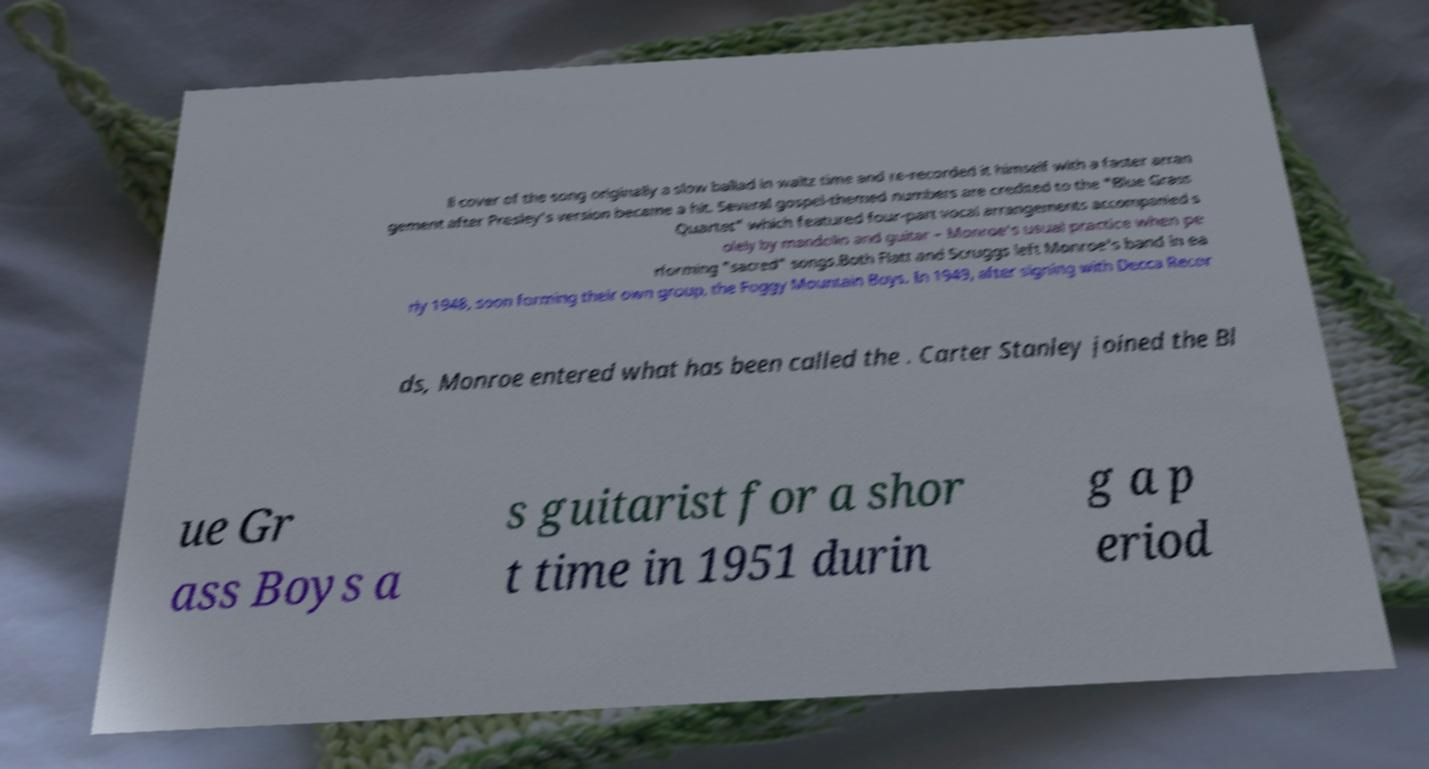Could you extract and type out the text from this image? ll cover of the song originally a slow ballad in waltz time and re-recorded it himself with a faster arran gement after Presley's version became a hit. Several gospel-themed numbers are credited to the "Blue Grass Quartet" which featured four-part vocal arrangements accompanied s olely by mandolin and guitar – Monroe's usual practice when pe rforming "sacred" songs.Both Flatt and Scruggs left Monroe's band in ea rly 1948, soon forming their own group, the Foggy Mountain Boys. In 1949, after signing with Decca Recor ds, Monroe entered what has been called the . Carter Stanley joined the Bl ue Gr ass Boys a s guitarist for a shor t time in 1951 durin g a p eriod 